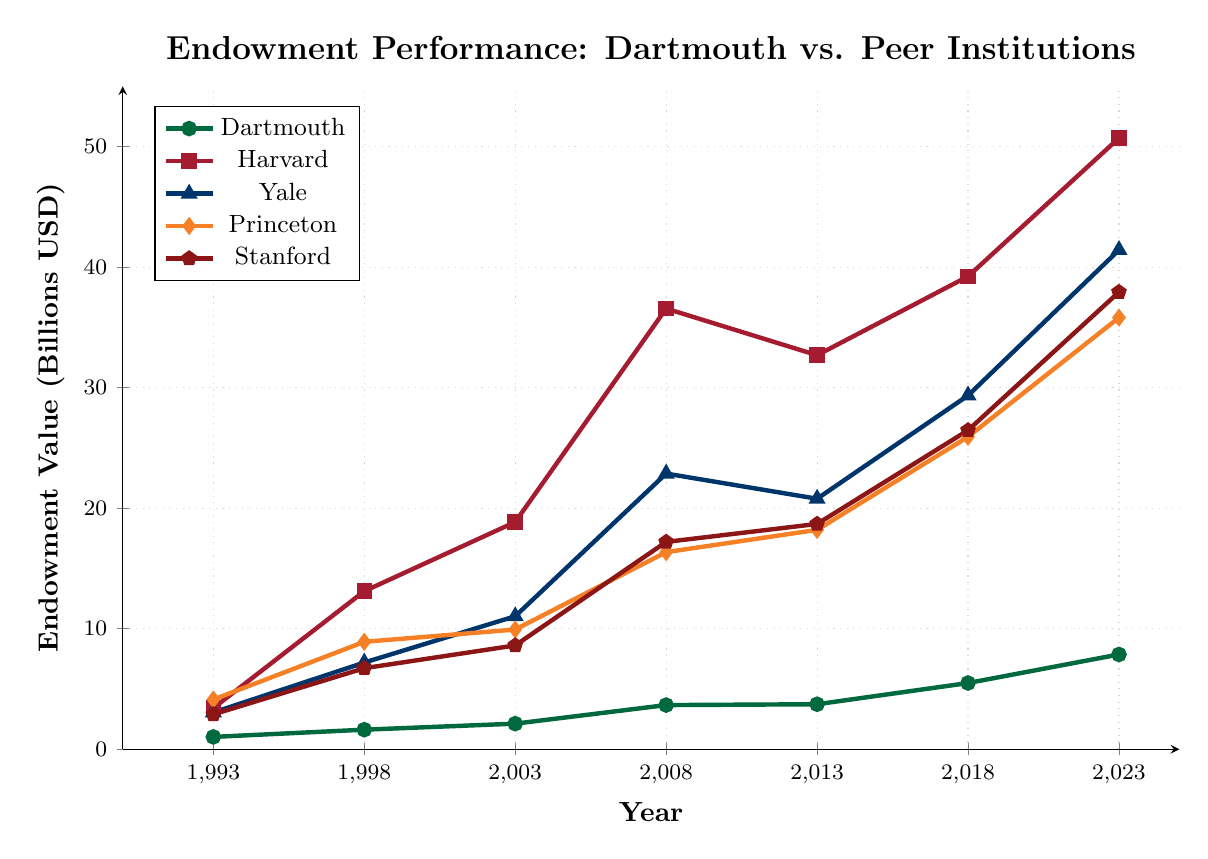What was Dartmouth's endowment value in 1993 and 2023? In 1993, Dartmouth's endowment value was at its initial point on the chart, and in 2023, it was at its endpoint. Since the line is marked with dots at these points, we see that Dartmouth's endowment value in 1993 was 1.02 billion USD and in 2023 was 7.86 billion USD.
Answer: 1.02 billion USD and 7.86 billion USD How does Dartmouth's endowment growth from 1993 to 2023 compare to Princeton's over the same period? Dartmouth's endowment grew from 1.02 billion USD in 1993 to 7.86 billion USD in 2023. This gives a growth of 7.86 - 1.02 = 6.84 billion USD. For Princeton, the endowment grew from 4.12 billion USD in 1993 to 35.81 billion USD in 2023, giving a growth of 35.81 - 4.12 = 31.69 billion USD. Comparing these values, Princeton's growth is much larger.
Answer: Dartmouth: 6.84 billion USD, Princeton: 31.69 billion USD Which institution had the highest endowment value in 2023? Looking at the 2023 endpoint of each line on the chart, Harvard has the highest endowment value at 50.71 billion USD.
Answer: Harvard Did any institution experience a decrease in endowment value between any of the years shown? By observing the line trends, all institutions show a generally upward trend. None of the lines show a downward movement between any of the specific years listed, indicating no decreases in endowment values.
Answer: No What is the difference between Stanford's and Yale's endowment values in 2018? According to the chart, in 2018, Yale's endowment was 29.35 billion USD and Stanford's was 26.46 billion USD. The difference is calculated as 29.35 - 26.46 = 2.89 billion USD.
Answer: 2.89 billion USD What was the average endowment value of Yale from 1993 to 2023? The values for Yale are: 3.05 (1993), 7.19 (1998), 11.03 (2003), 22.87 (2008), 20.78 (2013), 29.35 (2018), 41.42 (2023). Adding these together: 3.05 + 7.19 + 11.03 + 22.87 + 20.78 + 29.35 + 41.42 = 135.69. The average over 7 years is 135.69 / 7 ≈ 19.38 billion USD.
Answer: 19.38 billion USD In which period did Dartmouth's endowment grow the most? To find the period of most significant growth, we calculate the differences between each successive year's endowment values for Dartmouth: 
From 1993 to 1998: 1.62 - 1.02 = 0.60 billion USD,
From 1998 to 2003: 2.12 - 1.62 = 0.50 billion USD,
From 2003 to 2008: 3.66 - 2.12 = 1.54 billion USD,
From 2008 to 2013: 3.73 - 3.66 = 0.07 billion USD,
From 2013 to 2018: 5.49 - 3.73 = 1.76 billion USD,
From 2018 to 2023: 7.86 - 5.49 = 2.37 billion USD.
The most significant growth was from 2018 to 2023.
Answer: 2018 to 2023 How does the pattern of Harvard's endowment changes compared to Dartmouth's? Harvard's endowment shows a more accelerated growth pattern compared to Dartmouth's. For instance, Harvard's jump between 1998 and 2003 is significant (an increase of 5.74 billion USD), while Dartmouth's increases are more modest and steady. Specifically, Harvard shows sharp increases in many intervals, especially between 1998-2003 and 2003-2008, whereas Dartmouth’s increases, while steady, are much smaller for each period.
Answer: Harvard's growth is more accelerated and sharper; Dartmouth's is steady and modest In 2008, which institution had an endowment value closest to Dartmouth's? In 2008, Dartmouth's endowment was 3.66 billion USD. Comparing this value with those of other institutions: Harvard (36.56), Yale (22.87), Princeton (16.35), Stanford (17.20), we see that none of them are close to Dartmouth's value. All other institutions have much higher values.
Answer: None 